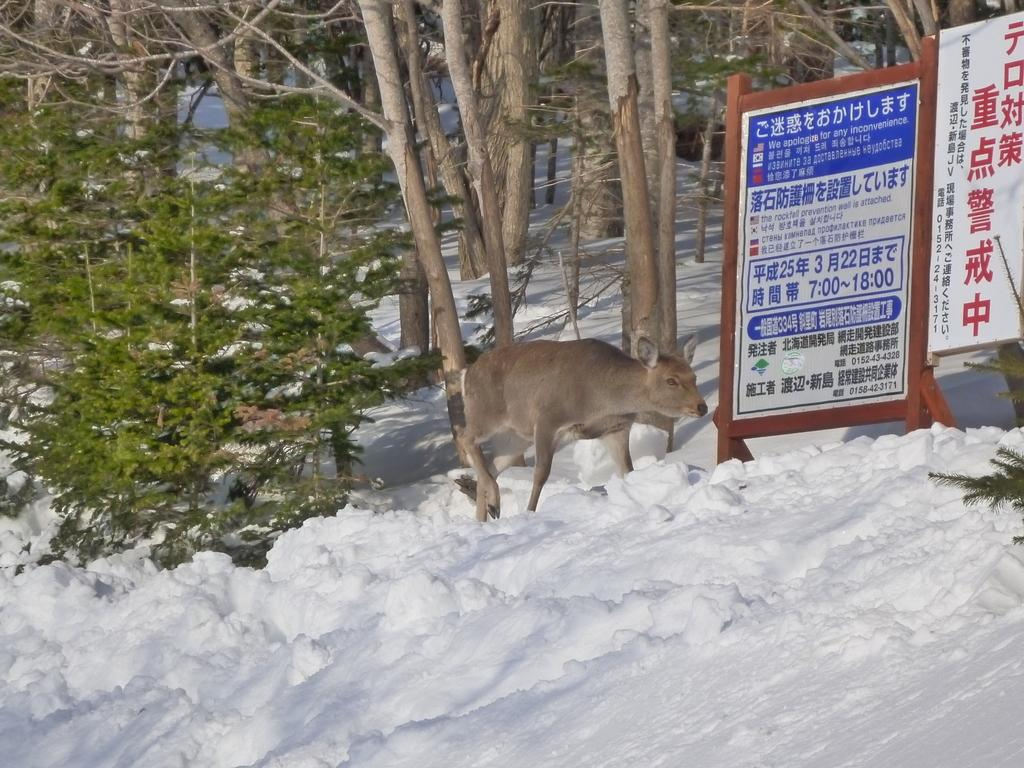What type of living creature is in the image? There is an animal in the image. What type of natural environment is depicted in the image? There are trees and plants in the image. What man-made objects can be seen in the image? There are boats in the image. Is there any text visible in the image? Yes, there is text visible on the boats. What type of bell can be heard ringing in the image? There is no bell present in the image, and therefore no sound can be heard. Can you describe the insect that is crawling on the animal in the image? There is no insect visible in the image; only the animal, trees, plants, boats, and text are present. 